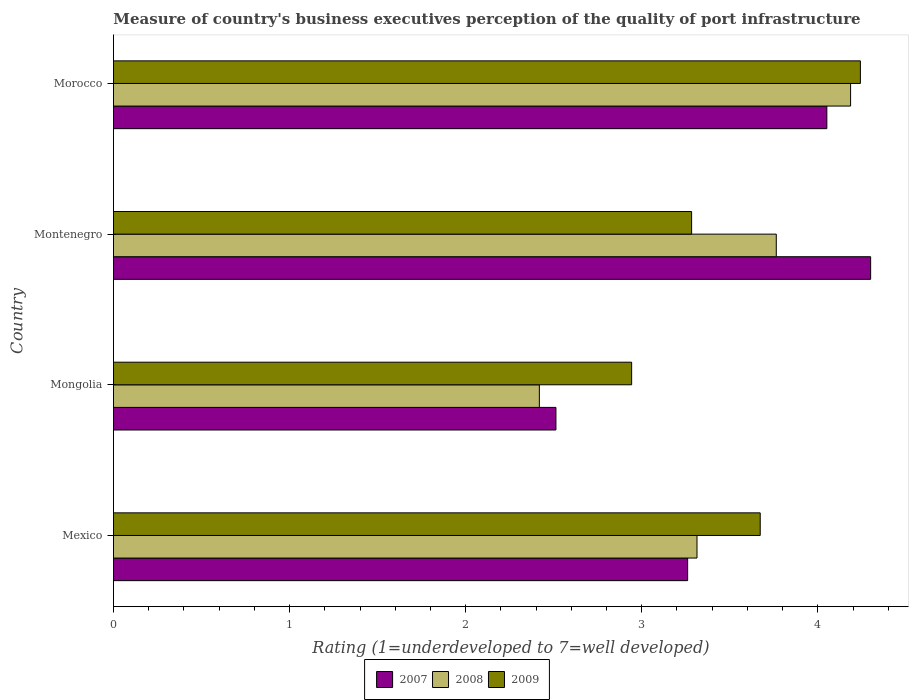How many groups of bars are there?
Provide a succinct answer. 4. Are the number of bars on each tick of the Y-axis equal?
Provide a succinct answer. Yes. How many bars are there on the 1st tick from the top?
Provide a succinct answer. 3. How many bars are there on the 4th tick from the bottom?
Keep it short and to the point. 3. What is the label of the 2nd group of bars from the top?
Offer a very short reply. Montenegro. What is the ratings of the quality of port infrastructure in 2009 in Mongolia?
Provide a short and direct response. 2.94. Across all countries, what is the maximum ratings of the quality of port infrastructure in 2008?
Provide a short and direct response. 4.19. Across all countries, what is the minimum ratings of the quality of port infrastructure in 2009?
Your answer should be very brief. 2.94. In which country was the ratings of the quality of port infrastructure in 2008 maximum?
Provide a succinct answer. Morocco. In which country was the ratings of the quality of port infrastructure in 2007 minimum?
Give a very brief answer. Mongolia. What is the total ratings of the quality of port infrastructure in 2009 in the graph?
Make the answer very short. 14.14. What is the difference between the ratings of the quality of port infrastructure in 2008 in Montenegro and that in Morocco?
Give a very brief answer. -0.42. What is the difference between the ratings of the quality of port infrastructure in 2008 in Mongolia and the ratings of the quality of port infrastructure in 2007 in Morocco?
Ensure brevity in your answer.  -1.63. What is the average ratings of the quality of port infrastructure in 2009 per country?
Keep it short and to the point. 3.54. What is the difference between the ratings of the quality of port infrastructure in 2008 and ratings of the quality of port infrastructure in 2007 in Montenegro?
Offer a terse response. -0.54. In how many countries, is the ratings of the quality of port infrastructure in 2009 greater than 4.2 ?
Your answer should be very brief. 1. What is the ratio of the ratings of the quality of port infrastructure in 2007 in Mexico to that in Mongolia?
Provide a succinct answer. 1.3. What is the difference between the highest and the second highest ratings of the quality of port infrastructure in 2008?
Provide a short and direct response. 0.42. What is the difference between the highest and the lowest ratings of the quality of port infrastructure in 2008?
Give a very brief answer. 1.77. Is the sum of the ratings of the quality of port infrastructure in 2009 in Mongolia and Montenegro greater than the maximum ratings of the quality of port infrastructure in 2007 across all countries?
Provide a succinct answer. Yes. What does the 1st bar from the bottom in Morocco represents?
Keep it short and to the point. 2007. How many bars are there?
Your response must be concise. 12. How many countries are there in the graph?
Your answer should be compact. 4. What is the difference between two consecutive major ticks on the X-axis?
Keep it short and to the point. 1. Are the values on the major ticks of X-axis written in scientific E-notation?
Make the answer very short. No. Does the graph contain any zero values?
Offer a terse response. No. Does the graph contain grids?
Offer a terse response. No. Where does the legend appear in the graph?
Offer a very short reply. Bottom center. How many legend labels are there?
Make the answer very short. 3. What is the title of the graph?
Provide a succinct answer. Measure of country's business executives perception of the quality of port infrastructure. Does "1977" appear as one of the legend labels in the graph?
Provide a short and direct response. No. What is the label or title of the X-axis?
Your answer should be very brief. Rating (1=underdeveloped to 7=well developed). What is the label or title of the Y-axis?
Provide a short and direct response. Country. What is the Rating (1=underdeveloped to 7=well developed) of 2007 in Mexico?
Provide a succinct answer. 3.26. What is the Rating (1=underdeveloped to 7=well developed) in 2008 in Mexico?
Your response must be concise. 3.31. What is the Rating (1=underdeveloped to 7=well developed) of 2009 in Mexico?
Offer a very short reply. 3.67. What is the Rating (1=underdeveloped to 7=well developed) in 2007 in Mongolia?
Your answer should be compact. 2.51. What is the Rating (1=underdeveloped to 7=well developed) in 2008 in Mongolia?
Your answer should be very brief. 2.42. What is the Rating (1=underdeveloped to 7=well developed) of 2009 in Mongolia?
Offer a terse response. 2.94. What is the Rating (1=underdeveloped to 7=well developed) of 2007 in Montenegro?
Provide a short and direct response. 4.3. What is the Rating (1=underdeveloped to 7=well developed) of 2008 in Montenegro?
Provide a succinct answer. 3.76. What is the Rating (1=underdeveloped to 7=well developed) of 2009 in Montenegro?
Ensure brevity in your answer.  3.28. What is the Rating (1=underdeveloped to 7=well developed) of 2007 in Morocco?
Ensure brevity in your answer.  4.05. What is the Rating (1=underdeveloped to 7=well developed) of 2008 in Morocco?
Keep it short and to the point. 4.19. What is the Rating (1=underdeveloped to 7=well developed) of 2009 in Morocco?
Provide a succinct answer. 4.24. Across all countries, what is the maximum Rating (1=underdeveloped to 7=well developed) in 2008?
Provide a short and direct response. 4.19. Across all countries, what is the maximum Rating (1=underdeveloped to 7=well developed) in 2009?
Your response must be concise. 4.24. Across all countries, what is the minimum Rating (1=underdeveloped to 7=well developed) in 2007?
Offer a terse response. 2.51. Across all countries, what is the minimum Rating (1=underdeveloped to 7=well developed) of 2008?
Your answer should be very brief. 2.42. Across all countries, what is the minimum Rating (1=underdeveloped to 7=well developed) in 2009?
Your response must be concise. 2.94. What is the total Rating (1=underdeveloped to 7=well developed) of 2007 in the graph?
Offer a very short reply. 14.12. What is the total Rating (1=underdeveloped to 7=well developed) in 2008 in the graph?
Your response must be concise. 13.68. What is the total Rating (1=underdeveloped to 7=well developed) in 2009 in the graph?
Your answer should be compact. 14.14. What is the difference between the Rating (1=underdeveloped to 7=well developed) of 2007 in Mexico and that in Mongolia?
Provide a succinct answer. 0.75. What is the difference between the Rating (1=underdeveloped to 7=well developed) in 2008 in Mexico and that in Mongolia?
Your answer should be very brief. 0.9. What is the difference between the Rating (1=underdeveloped to 7=well developed) of 2009 in Mexico and that in Mongolia?
Your answer should be compact. 0.73. What is the difference between the Rating (1=underdeveloped to 7=well developed) of 2007 in Mexico and that in Montenegro?
Provide a succinct answer. -1.04. What is the difference between the Rating (1=underdeveloped to 7=well developed) in 2008 in Mexico and that in Montenegro?
Ensure brevity in your answer.  -0.45. What is the difference between the Rating (1=underdeveloped to 7=well developed) in 2009 in Mexico and that in Montenegro?
Provide a short and direct response. 0.39. What is the difference between the Rating (1=underdeveloped to 7=well developed) of 2007 in Mexico and that in Morocco?
Your answer should be compact. -0.79. What is the difference between the Rating (1=underdeveloped to 7=well developed) of 2008 in Mexico and that in Morocco?
Your answer should be very brief. -0.87. What is the difference between the Rating (1=underdeveloped to 7=well developed) in 2009 in Mexico and that in Morocco?
Your response must be concise. -0.57. What is the difference between the Rating (1=underdeveloped to 7=well developed) in 2007 in Mongolia and that in Montenegro?
Keep it short and to the point. -1.79. What is the difference between the Rating (1=underdeveloped to 7=well developed) of 2008 in Mongolia and that in Montenegro?
Your answer should be compact. -1.35. What is the difference between the Rating (1=underdeveloped to 7=well developed) in 2009 in Mongolia and that in Montenegro?
Your answer should be very brief. -0.34. What is the difference between the Rating (1=underdeveloped to 7=well developed) of 2007 in Mongolia and that in Morocco?
Give a very brief answer. -1.54. What is the difference between the Rating (1=underdeveloped to 7=well developed) in 2008 in Mongolia and that in Morocco?
Keep it short and to the point. -1.77. What is the difference between the Rating (1=underdeveloped to 7=well developed) of 2009 in Mongolia and that in Morocco?
Ensure brevity in your answer.  -1.3. What is the difference between the Rating (1=underdeveloped to 7=well developed) in 2007 in Montenegro and that in Morocco?
Ensure brevity in your answer.  0.25. What is the difference between the Rating (1=underdeveloped to 7=well developed) in 2008 in Montenegro and that in Morocco?
Offer a terse response. -0.42. What is the difference between the Rating (1=underdeveloped to 7=well developed) of 2009 in Montenegro and that in Morocco?
Make the answer very short. -0.96. What is the difference between the Rating (1=underdeveloped to 7=well developed) in 2007 in Mexico and the Rating (1=underdeveloped to 7=well developed) in 2008 in Mongolia?
Provide a succinct answer. 0.84. What is the difference between the Rating (1=underdeveloped to 7=well developed) of 2007 in Mexico and the Rating (1=underdeveloped to 7=well developed) of 2009 in Mongolia?
Your answer should be very brief. 0.32. What is the difference between the Rating (1=underdeveloped to 7=well developed) of 2008 in Mexico and the Rating (1=underdeveloped to 7=well developed) of 2009 in Mongolia?
Give a very brief answer. 0.37. What is the difference between the Rating (1=underdeveloped to 7=well developed) of 2007 in Mexico and the Rating (1=underdeveloped to 7=well developed) of 2008 in Montenegro?
Provide a succinct answer. -0.5. What is the difference between the Rating (1=underdeveloped to 7=well developed) in 2007 in Mexico and the Rating (1=underdeveloped to 7=well developed) in 2009 in Montenegro?
Ensure brevity in your answer.  -0.02. What is the difference between the Rating (1=underdeveloped to 7=well developed) in 2008 in Mexico and the Rating (1=underdeveloped to 7=well developed) in 2009 in Montenegro?
Your response must be concise. 0.03. What is the difference between the Rating (1=underdeveloped to 7=well developed) of 2007 in Mexico and the Rating (1=underdeveloped to 7=well developed) of 2008 in Morocco?
Your response must be concise. -0.93. What is the difference between the Rating (1=underdeveloped to 7=well developed) of 2007 in Mexico and the Rating (1=underdeveloped to 7=well developed) of 2009 in Morocco?
Your answer should be very brief. -0.98. What is the difference between the Rating (1=underdeveloped to 7=well developed) of 2008 in Mexico and the Rating (1=underdeveloped to 7=well developed) of 2009 in Morocco?
Offer a terse response. -0.93. What is the difference between the Rating (1=underdeveloped to 7=well developed) of 2007 in Mongolia and the Rating (1=underdeveloped to 7=well developed) of 2008 in Montenegro?
Offer a very short reply. -1.25. What is the difference between the Rating (1=underdeveloped to 7=well developed) in 2007 in Mongolia and the Rating (1=underdeveloped to 7=well developed) in 2009 in Montenegro?
Keep it short and to the point. -0.77. What is the difference between the Rating (1=underdeveloped to 7=well developed) of 2008 in Mongolia and the Rating (1=underdeveloped to 7=well developed) of 2009 in Montenegro?
Your answer should be very brief. -0.86. What is the difference between the Rating (1=underdeveloped to 7=well developed) of 2007 in Mongolia and the Rating (1=underdeveloped to 7=well developed) of 2008 in Morocco?
Offer a very short reply. -1.67. What is the difference between the Rating (1=underdeveloped to 7=well developed) of 2007 in Mongolia and the Rating (1=underdeveloped to 7=well developed) of 2009 in Morocco?
Keep it short and to the point. -1.73. What is the difference between the Rating (1=underdeveloped to 7=well developed) of 2008 in Mongolia and the Rating (1=underdeveloped to 7=well developed) of 2009 in Morocco?
Offer a very short reply. -1.82. What is the difference between the Rating (1=underdeveloped to 7=well developed) in 2007 in Montenegro and the Rating (1=underdeveloped to 7=well developed) in 2008 in Morocco?
Your response must be concise. 0.11. What is the difference between the Rating (1=underdeveloped to 7=well developed) of 2007 in Montenegro and the Rating (1=underdeveloped to 7=well developed) of 2009 in Morocco?
Keep it short and to the point. 0.06. What is the difference between the Rating (1=underdeveloped to 7=well developed) in 2008 in Montenegro and the Rating (1=underdeveloped to 7=well developed) in 2009 in Morocco?
Your answer should be compact. -0.48. What is the average Rating (1=underdeveloped to 7=well developed) of 2007 per country?
Your response must be concise. 3.53. What is the average Rating (1=underdeveloped to 7=well developed) in 2008 per country?
Your response must be concise. 3.42. What is the average Rating (1=underdeveloped to 7=well developed) of 2009 per country?
Ensure brevity in your answer.  3.54. What is the difference between the Rating (1=underdeveloped to 7=well developed) of 2007 and Rating (1=underdeveloped to 7=well developed) of 2008 in Mexico?
Keep it short and to the point. -0.05. What is the difference between the Rating (1=underdeveloped to 7=well developed) of 2007 and Rating (1=underdeveloped to 7=well developed) of 2009 in Mexico?
Provide a succinct answer. -0.41. What is the difference between the Rating (1=underdeveloped to 7=well developed) of 2008 and Rating (1=underdeveloped to 7=well developed) of 2009 in Mexico?
Your response must be concise. -0.36. What is the difference between the Rating (1=underdeveloped to 7=well developed) of 2007 and Rating (1=underdeveloped to 7=well developed) of 2008 in Mongolia?
Offer a very short reply. 0.09. What is the difference between the Rating (1=underdeveloped to 7=well developed) in 2007 and Rating (1=underdeveloped to 7=well developed) in 2009 in Mongolia?
Make the answer very short. -0.43. What is the difference between the Rating (1=underdeveloped to 7=well developed) of 2008 and Rating (1=underdeveloped to 7=well developed) of 2009 in Mongolia?
Provide a succinct answer. -0.52. What is the difference between the Rating (1=underdeveloped to 7=well developed) of 2007 and Rating (1=underdeveloped to 7=well developed) of 2008 in Montenegro?
Your answer should be very brief. 0.54. What is the difference between the Rating (1=underdeveloped to 7=well developed) in 2007 and Rating (1=underdeveloped to 7=well developed) in 2009 in Montenegro?
Your response must be concise. 1.02. What is the difference between the Rating (1=underdeveloped to 7=well developed) of 2008 and Rating (1=underdeveloped to 7=well developed) of 2009 in Montenegro?
Keep it short and to the point. 0.48. What is the difference between the Rating (1=underdeveloped to 7=well developed) of 2007 and Rating (1=underdeveloped to 7=well developed) of 2008 in Morocco?
Your response must be concise. -0.13. What is the difference between the Rating (1=underdeveloped to 7=well developed) of 2007 and Rating (1=underdeveloped to 7=well developed) of 2009 in Morocco?
Give a very brief answer. -0.19. What is the difference between the Rating (1=underdeveloped to 7=well developed) in 2008 and Rating (1=underdeveloped to 7=well developed) in 2009 in Morocco?
Provide a short and direct response. -0.06. What is the ratio of the Rating (1=underdeveloped to 7=well developed) in 2007 in Mexico to that in Mongolia?
Ensure brevity in your answer.  1.3. What is the ratio of the Rating (1=underdeveloped to 7=well developed) in 2008 in Mexico to that in Mongolia?
Offer a terse response. 1.37. What is the ratio of the Rating (1=underdeveloped to 7=well developed) in 2009 in Mexico to that in Mongolia?
Keep it short and to the point. 1.25. What is the ratio of the Rating (1=underdeveloped to 7=well developed) in 2007 in Mexico to that in Montenegro?
Keep it short and to the point. 0.76. What is the ratio of the Rating (1=underdeveloped to 7=well developed) of 2008 in Mexico to that in Montenegro?
Give a very brief answer. 0.88. What is the ratio of the Rating (1=underdeveloped to 7=well developed) in 2009 in Mexico to that in Montenegro?
Your answer should be compact. 1.12. What is the ratio of the Rating (1=underdeveloped to 7=well developed) of 2007 in Mexico to that in Morocco?
Your response must be concise. 0.8. What is the ratio of the Rating (1=underdeveloped to 7=well developed) of 2008 in Mexico to that in Morocco?
Your answer should be very brief. 0.79. What is the ratio of the Rating (1=underdeveloped to 7=well developed) in 2009 in Mexico to that in Morocco?
Your answer should be compact. 0.87. What is the ratio of the Rating (1=underdeveloped to 7=well developed) of 2007 in Mongolia to that in Montenegro?
Your response must be concise. 0.58. What is the ratio of the Rating (1=underdeveloped to 7=well developed) of 2008 in Mongolia to that in Montenegro?
Your answer should be very brief. 0.64. What is the ratio of the Rating (1=underdeveloped to 7=well developed) in 2009 in Mongolia to that in Montenegro?
Give a very brief answer. 0.9. What is the ratio of the Rating (1=underdeveloped to 7=well developed) in 2007 in Mongolia to that in Morocco?
Your answer should be very brief. 0.62. What is the ratio of the Rating (1=underdeveloped to 7=well developed) in 2008 in Mongolia to that in Morocco?
Keep it short and to the point. 0.58. What is the ratio of the Rating (1=underdeveloped to 7=well developed) of 2009 in Mongolia to that in Morocco?
Keep it short and to the point. 0.69. What is the ratio of the Rating (1=underdeveloped to 7=well developed) of 2007 in Montenegro to that in Morocco?
Give a very brief answer. 1.06. What is the ratio of the Rating (1=underdeveloped to 7=well developed) of 2008 in Montenegro to that in Morocco?
Provide a succinct answer. 0.9. What is the ratio of the Rating (1=underdeveloped to 7=well developed) in 2009 in Montenegro to that in Morocco?
Make the answer very short. 0.77. What is the difference between the highest and the second highest Rating (1=underdeveloped to 7=well developed) in 2007?
Offer a terse response. 0.25. What is the difference between the highest and the second highest Rating (1=underdeveloped to 7=well developed) of 2008?
Give a very brief answer. 0.42. What is the difference between the highest and the second highest Rating (1=underdeveloped to 7=well developed) of 2009?
Offer a very short reply. 0.57. What is the difference between the highest and the lowest Rating (1=underdeveloped to 7=well developed) of 2007?
Make the answer very short. 1.79. What is the difference between the highest and the lowest Rating (1=underdeveloped to 7=well developed) in 2008?
Provide a short and direct response. 1.77. What is the difference between the highest and the lowest Rating (1=underdeveloped to 7=well developed) in 2009?
Provide a short and direct response. 1.3. 